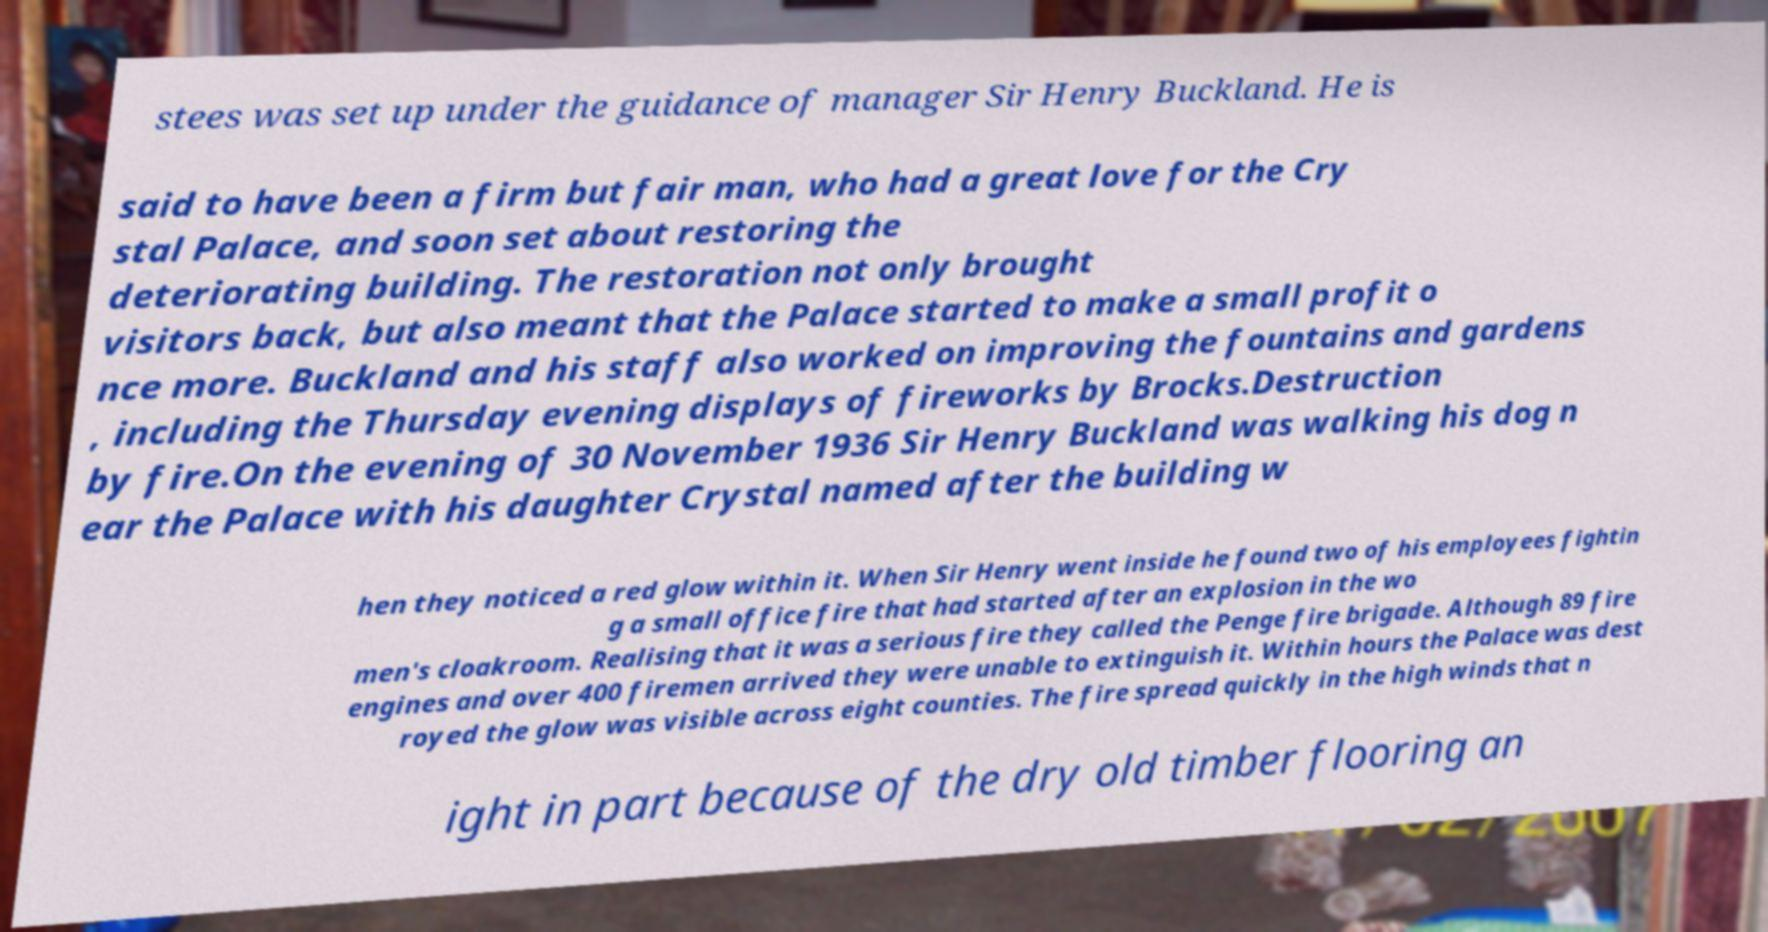Can you read and provide the text displayed in the image?This photo seems to have some interesting text. Can you extract and type it out for me? stees was set up under the guidance of manager Sir Henry Buckland. He is said to have been a firm but fair man, who had a great love for the Cry stal Palace, and soon set about restoring the deteriorating building. The restoration not only brought visitors back, but also meant that the Palace started to make a small profit o nce more. Buckland and his staff also worked on improving the fountains and gardens , including the Thursday evening displays of fireworks by Brocks.Destruction by fire.On the evening of 30 November 1936 Sir Henry Buckland was walking his dog n ear the Palace with his daughter Crystal named after the building w hen they noticed a red glow within it. When Sir Henry went inside he found two of his employees fightin g a small office fire that had started after an explosion in the wo men's cloakroom. Realising that it was a serious fire they called the Penge fire brigade. Although 89 fire engines and over 400 firemen arrived they were unable to extinguish it. Within hours the Palace was dest royed the glow was visible across eight counties. The fire spread quickly in the high winds that n ight in part because of the dry old timber flooring an 